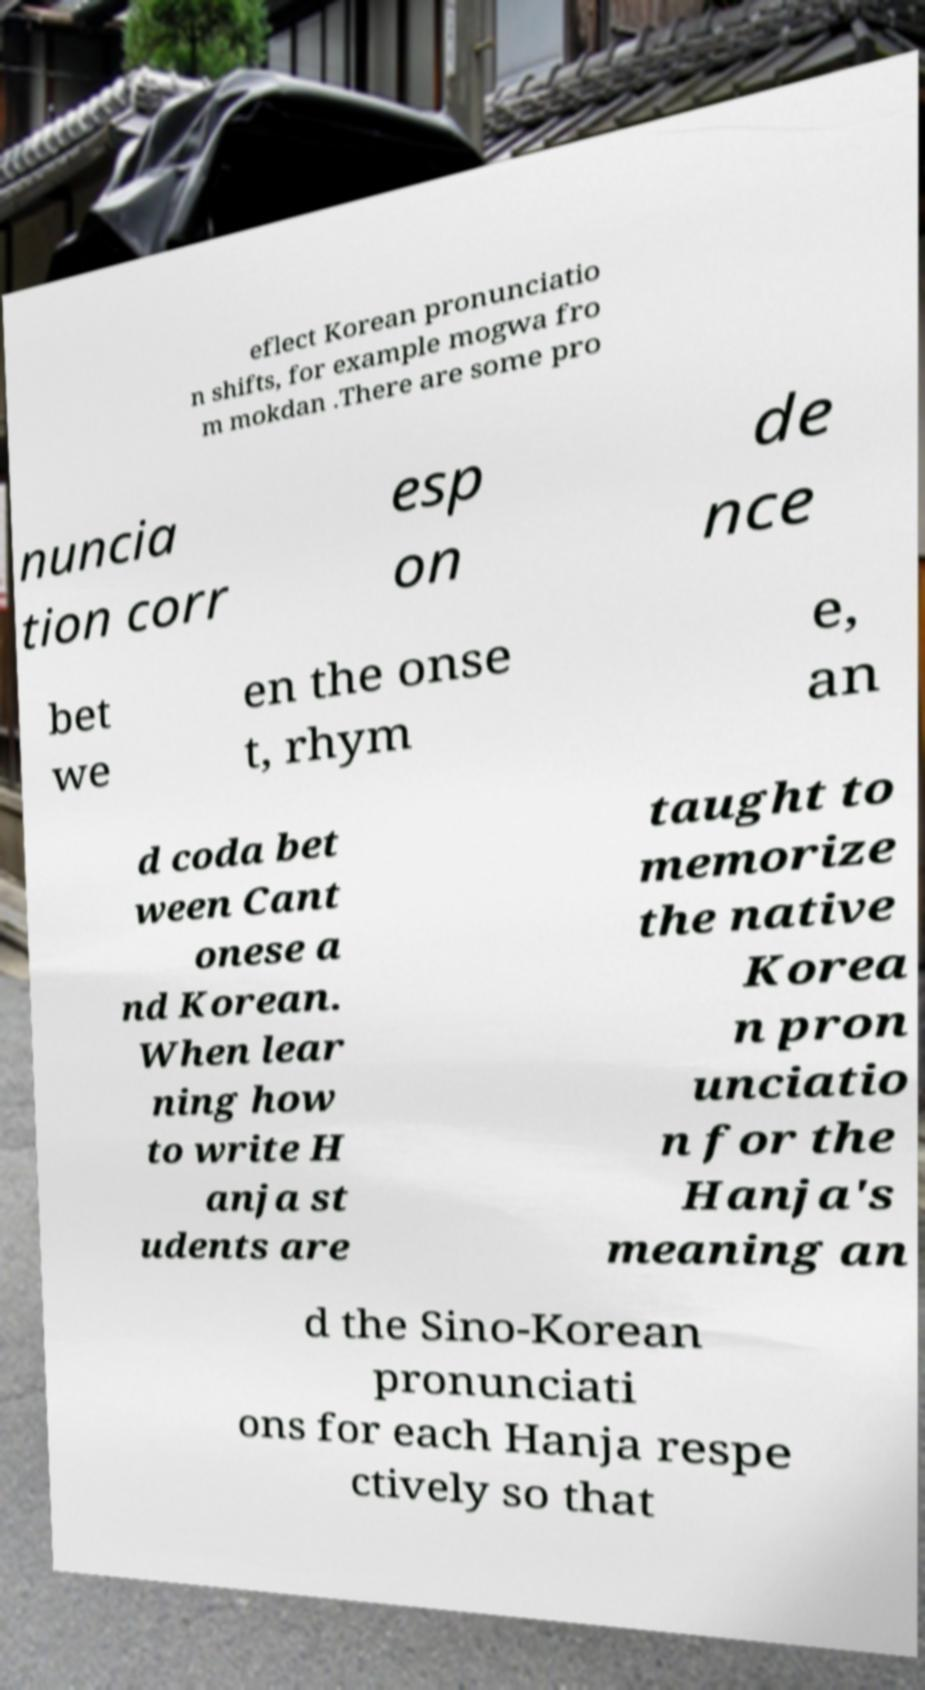Could you assist in decoding the text presented in this image and type it out clearly? eflect Korean pronunciatio n shifts, for example mogwa fro m mokdan .There are some pro nuncia tion corr esp on de nce bet we en the onse t, rhym e, an d coda bet ween Cant onese a nd Korean. When lear ning how to write H anja st udents are taught to memorize the native Korea n pron unciatio n for the Hanja's meaning an d the Sino-Korean pronunciati ons for each Hanja respe ctively so that 